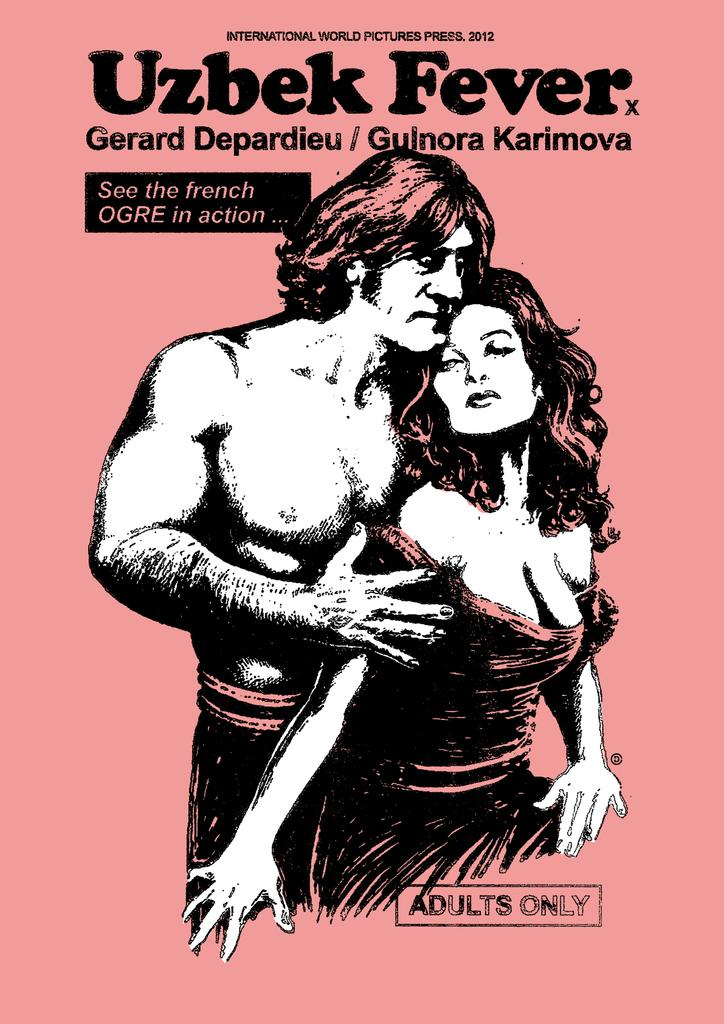What is depicted in the center of the image? There is a drawing of a man and a woman in the center of the image. What are the man and woman doing in the drawing? The man and woman are standing in the drawing. What else can be found on the image besides the drawing? There is text on the image. What type of ring is the man wearing in the image? There is no ring visible on the man in the image, as it is a drawing of a man and woman, not a photograph. 